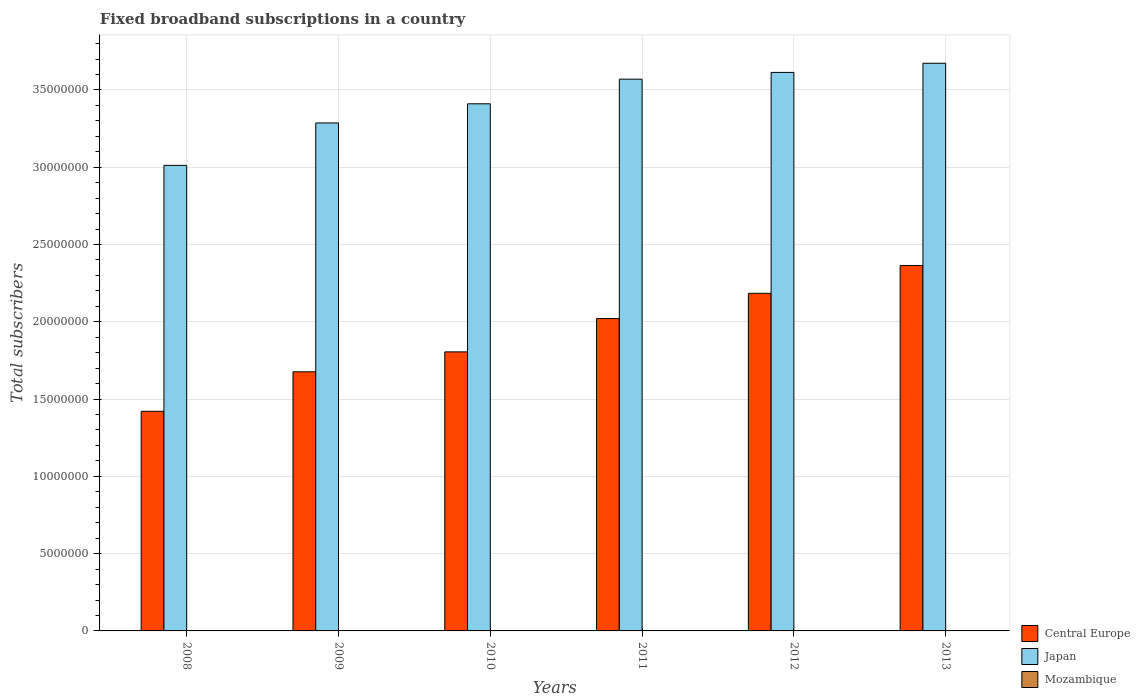How many different coloured bars are there?
Your answer should be very brief. 3. How many groups of bars are there?
Keep it short and to the point. 6. How many bars are there on the 3rd tick from the left?
Provide a short and direct response. 3. How many bars are there on the 1st tick from the right?
Provide a succinct answer. 3. In how many cases, is the number of bars for a given year not equal to the number of legend labels?
Offer a terse response. 0. What is the number of broadband subscriptions in Mozambique in 2011?
Give a very brief answer. 2.12e+04. Across all years, what is the maximum number of broadband subscriptions in Central Europe?
Make the answer very short. 2.36e+07. Across all years, what is the minimum number of broadband subscriptions in Japan?
Your response must be concise. 3.01e+07. In which year was the number of broadband subscriptions in Central Europe maximum?
Offer a very short reply. 2013. What is the total number of broadband subscriptions in Japan in the graph?
Provide a succinct answer. 2.06e+08. What is the difference between the number of broadband subscriptions in Japan in 2012 and that in 2013?
Give a very brief answer. -5.92e+05. What is the difference between the number of broadband subscriptions in Mozambique in 2012 and the number of broadband subscriptions in Central Europe in 2013?
Ensure brevity in your answer.  -2.36e+07. What is the average number of broadband subscriptions in Mozambique per year?
Give a very brief answer. 1.62e+04. In the year 2013, what is the difference between the number of broadband subscriptions in Japan and number of broadband subscriptions in Central Europe?
Your answer should be compact. 1.31e+07. What is the ratio of the number of broadband subscriptions in Japan in 2010 to that in 2013?
Offer a very short reply. 0.93. Is the number of broadband subscriptions in Japan in 2009 less than that in 2010?
Your response must be concise. Yes. What is the difference between the highest and the second highest number of broadband subscriptions in Japan?
Make the answer very short. 5.92e+05. What is the difference between the highest and the lowest number of broadband subscriptions in Japan?
Your answer should be compact. 6.61e+06. In how many years, is the number of broadband subscriptions in Mozambique greater than the average number of broadband subscriptions in Mozambique taken over all years?
Give a very brief answer. 3. Is the sum of the number of broadband subscriptions in Japan in 2008 and 2011 greater than the maximum number of broadband subscriptions in Mozambique across all years?
Offer a very short reply. Yes. What does the 1st bar from the left in 2008 represents?
Give a very brief answer. Central Europe. What does the 1st bar from the right in 2013 represents?
Provide a succinct answer. Mozambique. Is it the case that in every year, the sum of the number of broadband subscriptions in Mozambique and number of broadband subscriptions in Central Europe is greater than the number of broadband subscriptions in Japan?
Make the answer very short. No. How many bars are there?
Give a very brief answer. 18. Are all the bars in the graph horizontal?
Make the answer very short. No. What is the difference between two consecutive major ticks on the Y-axis?
Keep it short and to the point. 5.00e+06. Are the values on the major ticks of Y-axis written in scientific E-notation?
Provide a short and direct response. No. Where does the legend appear in the graph?
Offer a very short reply. Bottom right. How many legend labels are there?
Keep it short and to the point. 3. What is the title of the graph?
Your response must be concise. Fixed broadband subscriptions in a country. What is the label or title of the Y-axis?
Offer a terse response. Total subscribers. What is the Total subscribers in Central Europe in 2008?
Ensure brevity in your answer.  1.42e+07. What is the Total subscribers of Japan in 2008?
Ensure brevity in your answer.  3.01e+07. What is the Total subscribers of Mozambique in 2008?
Your response must be concise. 1.02e+04. What is the Total subscribers of Central Europe in 2009?
Keep it short and to the point. 1.68e+07. What is the Total subscribers of Japan in 2009?
Ensure brevity in your answer.  3.29e+07. What is the Total subscribers of Mozambique in 2009?
Your answer should be compact. 1.25e+04. What is the Total subscribers in Central Europe in 2010?
Make the answer very short. 1.81e+07. What is the Total subscribers of Japan in 2010?
Your answer should be very brief. 3.41e+07. What is the Total subscribers in Mozambique in 2010?
Your response must be concise. 1.46e+04. What is the Total subscribers in Central Europe in 2011?
Provide a short and direct response. 2.02e+07. What is the Total subscribers of Japan in 2011?
Provide a succinct answer. 3.57e+07. What is the Total subscribers in Mozambique in 2011?
Offer a very short reply. 2.12e+04. What is the Total subscribers in Central Europe in 2012?
Offer a terse response. 2.18e+07. What is the Total subscribers of Japan in 2012?
Your answer should be compact. 3.61e+07. What is the Total subscribers in Mozambique in 2012?
Offer a very short reply. 2.05e+04. What is the Total subscribers of Central Europe in 2013?
Provide a succinct answer. 2.36e+07. What is the Total subscribers of Japan in 2013?
Give a very brief answer. 3.67e+07. What is the Total subscribers in Mozambique in 2013?
Offer a very short reply. 1.80e+04. Across all years, what is the maximum Total subscribers of Central Europe?
Your answer should be compact. 2.36e+07. Across all years, what is the maximum Total subscribers of Japan?
Your answer should be very brief. 3.67e+07. Across all years, what is the maximum Total subscribers of Mozambique?
Offer a terse response. 2.12e+04. Across all years, what is the minimum Total subscribers in Central Europe?
Offer a terse response. 1.42e+07. Across all years, what is the minimum Total subscribers in Japan?
Keep it short and to the point. 3.01e+07. Across all years, what is the minimum Total subscribers in Mozambique?
Provide a succinct answer. 1.02e+04. What is the total Total subscribers of Central Europe in the graph?
Keep it short and to the point. 1.15e+08. What is the total Total subscribers of Japan in the graph?
Your answer should be compact. 2.06e+08. What is the total Total subscribers of Mozambique in the graph?
Your answer should be very brief. 9.70e+04. What is the difference between the Total subscribers in Central Europe in 2008 and that in 2009?
Give a very brief answer. -2.55e+06. What is the difference between the Total subscribers in Japan in 2008 and that in 2009?
Your answer should be very brief. -2.75e+06. What is the difference between the Total subscribers of Mozambique in 2008 and that in 2009?
Offer a terse response. -2311. What is the difference between the Total subscribers in Central Europe in 2008 and that in 2010?
Your answer should be very brief. -3.84e+06. What is the difference between the Total subscribers of Japan in 2008 and that in 2010?
Keep it short and to the point. -3.98e+06. What is the difference between the Total subscribers in Mozambique in 2008 and that in 2010?
Offer a terse response. -4442. What is the difference between the Total subscribers of Central Europe in 2008 and that in 2011?
Your answer should be very brief. -6.00e+06. What is the difference between the Total subscribers of Japan in 2008 and that in 2011?
Offer a very short reply. -5.58e+06. What is the difference between the Total subscribers of Mozambique in 2008 and that in 2011?
Keep it short and to the point. -1.10e+04. What is the difference between the Total subscribers in Central Europe in 2008 and that in 2012?
Your answer should be compact. -7.63e+06. What is the difference between the Total subscribers of Japan in 2008 and that in 2012?
Your response must be concise. -6.01e+06. What is the difference between the Total subscribers of Mozambique in 2008 and that in 2012?
Ensure brevity in your answer.  -1.03e+04. What is the difference between the Total subscribers in Central Europe in 2008 and that in 2013?
Your answer should be very brief. -9.43e+06. What is the difference between the Total subscribers of Japan in 2008 and that in 2013?
Your response must be concise. -6.61e+06. What is the difference between the Total subscribers in Mozambique in 2008 and that in 2013?
Make the answer very short. -7792. What is the difference between the Total subscribers of Central Europe in 2009 and that in 2010?
Your answer should be compact. -1.29e+06. What is the difference between the Total subscribers of Japan in 2009 and that in 2010?
Give a very brief answer. -1.24e+06. What is the difference between the Total subscribers of Mozambique in 2009 and that in 2010?
Your response must be concise. -2131. What is the difference between the Total subscribers in Central Europe in 2009 and that in 2011?
Offer a terse response. -3.45e+06. What is the difference between the Total subscribers of Japan in 2009 and that in 2011?
Keep it short and to the point. -2.83e+06. What is the difference between the Total subscribers in Mozambique in 2009 and that in 2011?
Give a very brief answer. -8702. What is the difference between the Total subscribers of Central Europe in 2009 and that in 2012?
Provide a short and direct response. -5.08e+06. What is the difference between the Total subscribers of Japan in 2009 and that in 2012?
Make the answer very short. -3.27e+06. What is the difference between the Total subscribers of Mozambique in 2009 and that in 2012?
Your answer should be compact. -7982. What is the difference between the Total subscribers in Central Europe in 2009 and that in 2013?
Your response must be concise. -6.87e+06. What is the difference between the Total subscribers of Japan in 2009 and that in 2013?
Give a very brief answer. -3.86e+06. What is the difference between the Total subscribers in Mozambique in 2009 and that in 2013?
Give a very brief answer. -5481. What is the difference between the Total subscribers in Central Europe in 2010 and that in 2011?
Your answer should be very brief. -2.16e+06. What is the difference between the Total subscribers in Japan in 2010 and that in 2011?
Your answer should be very brief. -1.59e+06. What is the difference between the Total subscribers of Mozambique in 2010 and that in 2011?
Provide a short and direct response. -6571. What is the difference between the Total subscribers in Central Europe in 2010 and that in 2012?
Give a very brief answer. -3.79e+06. What is the difference between the Total subscribers of Japan in 2010 and that in 2012?
Your answer should be compact. -2.03e+06. What is the difference between the Total subscribers in Mozambique in 2010 and that in 2012?
Your answer should be compact. -5851. What is the difference between the Total subscribers of Central Europe in 2010 and that in 2013?
Your response must be concise. -5.59e+06. What is the difference between the Total subscribers of Japan in 2010 and that in 2013?
Keep it short and to the point. -2.62e+06. What is the difference between the Total subscribers of Mozambique in 2010 and that in 2013?
Offer a very short reply. -3350. What is the difference between the Total subscribers in Central Europe in 2011 and that in 2012?
Keep it short and to the point. -1.63e+06. What is the difference between the Total subscribers in Japan in 2011 and that in 2012?
Your answer should be compact. -4.36e+05. What is the difference between the Total subscribers in Mozambique in 2011 and that in 2012?
Ensure brevity in your answer.  720. What is the difference between the Total subscribers of Central Europe in 2011 and that in 2013?
Your response must be concise. -3.43e+06. What is the difference between the Total subscribers of Japan in 2011 and that in 2013?
Give a very brief answer. -1.03e+06. What is the difference between the Total subscribers of Mozambique in 2011 and that in 2013?
Give a very brief answer. 3221. What is the difference between the Total subscribers of Central Europe in 2012 and that in 2013?
Your response must be concise. -1.80e+06. What is the difference between the Total subscribers of Japan in 2012 and that in 2013?
Give a very brief answer. -5.92e+05. What is the difference between the Total subscribers in Mozambique in 2012 and that in 2013?
Offer a terse response. 2501. What is the difference between the Total subscribers in Central Europe in 2008 and the Total subscribers in Japan in 2009?
Offer a terse response. -1.87e+07. What is the difference between the Total subscribers in Central Europe in 2008 and the Total subscribers in Mozambique in 2009?
Provide a succinct answer. 1.42e+07. What is the difference between the Total subscribers in Japan in 2008 and the Total subscribers in Mozambique in 2009?
Offer a terse response. 3.01e+07. What is the difference between the Total subscribers in Central Europe in 2008 and the Total subscribers in Japan in 2010?
Provide a succinct answer. -1.99e+07. What is the difference between the Total subscribers of Central Europe in 2008 and the Total subscribers of Mozambique in 2010?
Your answer should be compact. 1.42e+07. What is the difference between the Total subscribers of Japan in 2008 and the Total subscribers of Mozambique in 2010?
Your answer should be very brief. 3.01e+07. What is the difference between the Total subscribers in Central Europe in 2008 and the Total subscribers in Japan in 2011?
Make the answer very short. -2.15e+07. What is the difference between the Total subscribers in Central Europe in 2008 and the Total subscribers in Mozambique in 2011?
Offer a very short reply. 1.42e+07. What is the difference between the Total subscribers in Japan in 2008 and the Total subscribers in Mozambique in 2011?
Make the answer very short. 3.01e+07. What is the difference between the Total subscribers of Central Europe in 2008 and the Total subscribers of Japan in 2012?
Provide a short and direct response. -2.19e+07. What is the difference between the Total subscribers in Central Europe in 2008 and the Total subscribers in Mozambique in 2012?
Make the answer very short. 1.42e+07. What is the difference between the Total subscribers of Japan in 2008 and the Total subscribers of Mozambique in 2012?
Give a very brief answer. 3.01e+07. What is the difference between the Total subscribers in Central Europe in 2008 and the Total subscribers in Japan in 2013?
Keep it short and to the point. -2.25e+07. What is the difference between the Total subscribers in Central Europe in 2008 and the Total subscribers in Mozambique in 2013?
Your response must be concise. 1.42e+07. What is the difference between the Total subscribers in Japan in 2008 and the Total subscribers in Mozambique in 2013?
Your response must be concise. 3.01e+07. What is the difference between the Total subscribers in Central Europe in 2009 and the Total subscribers in Japan in 2010?
Provide a succinct answer. -1.73e+07. What is the difference between the Total subscribers in Central Europe in 2009 and the Total subscribers in Mozambique in 2010?
Make the answer very short. 1.67e+07. What is the difference between the Total subscribers in Japan in 2009 and the Total subscribers in Mozambique in 2010?
Your response must be concise. 3.28e+07. What is the difference between the Total subscribers of Central Europe in 2009 and the Total subscribers of Japan in 2011?
Make the answer very short. -1.89e+07. What is the difference between the Total subscribers of Central Europe in 2009 and the Total subscribers of Mozambique in 2011?
Give a very brief answer. 1.67e+07. What is the difference between the Total subscribers in Japan in 2009 and the Total subscribers in Mozambique in 2011?
Your answer should be compact. 3.28e+07. What is the difference between the Total subscribers of Central Europe in 2009 and the Total subscribers of Japan in 2012?
Make the answer very short. -1.94e+07. What is the difference between the Total subscribers of Central Europe in 2009 and the Total subscribers of Mozambique in 2012?
Offer a terse response. 1.67e+07. What is the difference between the Total subscribers in Japan in 2009 and the Total subscribers in Mozambique in 2012?
Your response must be concise. 3.28e+07. What is the difference between the Total subscribers of Central Europe in 2009 and the Total subscribers of Japan in 2013?
Provide a short and direct response. -2.00e+07. What is the difference between the Total subscribers in Central Europe in 2009 and the Total subscribers in Mozambique in 2013?
Provide a short and direct response. 1.67e+07. What is the difference between the Total subscribers of Japan in 2009 and the Total subscribers of Mozambique in 2013?
Provide a succinct answer. 3.28e+07. What is the difference between the Total subscribers in Central Europe in 2010 and the Total subscribers in Japan in 2011?
Provide a succinct answer. -1.76e+07. What is the difference between the Total subscribers of Central Europe in 2010 and the Total subscribers of Mozambique in 2011?
Provide a succinct answer. 1.80e+07. What is the difference between the Total subscribers in Japan in 2010 and the Total subscribers in Mozambique in 2011?
Give a very brief answer. 3.41e+07. What is the difference between the Total subscribers of Central Europe in 2010 and the Total subscribers of Japan in 2012?
Give a very brief answer. -1.81e+07. What is the difference between the Total subscribers of Central Europe in 2010 and the Total subscribers of Mozambique in 2012?
Your answer should be compact. 1.80e+07. What is the difference between the Total subscribers of Japan in 2010 and the Total subscribers of Mozambique in 2012?
Provide a succinct answer. 3.41e+07. What is the difference between the Total subscribers in Central Europe in 2010 and the Total subscribers in Japan in 2013?
Your answer should be compact. -1.87e+07. What is the difference between the Total subscribers of Central Europe in 2010 and the Total subscribers of Mozambique in 2013?
Offer a very short reply. 1.80e+07. What is the difference between the Total subscribers of Japan in 2010 and the Total subscribers of Mozambique in 2013?
Give a very brief answer. 3.41e+07. What is the difference between the Total subscribers in Central Europe in 2011 and the Total subscribers in Japan in 2012?
Make the answer very short. -1.59e+07. What is the difference between the Total subscribers of Central Europe in 2011 and the Total subscribers of Mozambique in 2012?
Provide a short and direct response. 2.02e+07. What is the difference between the Total subscribers in Japan in 2011 and the Total subscribers in Mozambique in 2012?
Ensure brevity in your answer.  3.57e+07. What is the difference between the Total subscribers in Central Europe in 2011 and the Total subscribers in Japan in 2013?
Offer a very short reply. -1.65e+07. What is the difference between the Total subscribers of Central Europe in 2011 and the Total subscribers of Mozambique in 2013?
Offer a very short reply. 2.02e+07. What is the difference between the Total subscribers in Japan in 2011 and the Total subscribers in Mozambique in 2013?
Offer a very short reply. 3.57e+07. What is the difference between the Total subscribers in Central Europe in 2012 and the Total subscribers in Japan in 2013?
Offer a terse response. -1.49e+07. What is the difference between the Total subscribers in Central Europe in 2012 and the Total subscribers in Mozambique in 2013?
Provide a short and direct response. 2.18e+07. What is the difference between the Total subscribers of Japan in 2012 and the Total subscribers of Mozambique in 2013?
Make the answer very short. 3.61e+07. What is the average Total subscribers of Central Europe per year?
Keep it short and to the point. 1.91e+07. What is the average Total subscribers in Japan per year?
Ensure brevity in your answer.  3.43e+07. What is the average Total subscribers in Mozambique per year?
Provide a succinct answer. 1.62e+04. In the year 2008, what is the difference between the Total subscribers of Central Europe and Total subscribers of Japan?
Make the answer very short. -1.59e+07. In the year 2008, what is the difference between the Total subscribers of Central Europe and Total subscribers of Mozambique?
Your answer should be compact. 1.42e+07. In the year 2008, what is the difference between the Total subscribers in Japan and Total subscribers in Mozambique?
Your answer should be compact. 3.01e+07. In the year 2009, what is the difference between the Total subscribers in Central Europe and Total subscribers in Japan?
Your answer should be very brief. -1.61e+07. In the year 2009, what is the difference between the Total subscribers of Central Europe and Total subscribers of Mozambique?
Offer a very short reply. 1.68e+07. In the year 2009, what is the difference between the Total subscribers of Japan and Total subscribers of Mozambique?
Provide a short and direct response. 3.29e+07. In the year 2010, what is the difference between the Total subscribers of Central Europe and Total subscribers of Japan?
Your answer should be very brief. -1.60e+07. In the year 2010, what is the difference between the Total subscribers in Central Europe and Total subscribers in Mozambique?
Keep it short and to the point. 1.80e+07. In the year 2010, what is the difference between the Total subscribers of Japan and Total subscribers of Mozambique?
Provide a short and direct response. 3.41e+07. In the year 2011, what is the difference between the Total subscribers of Central Europe and Total subscribers of Japan?
Keep it short and to the point. -1.55e+07. In the year 2011, what is the difference between the Total subscribers in Central Europe and Total subscribers in Mozambique?
Your response must be concise. 2.02e+07. In the year 2011, what is the difference between the Total subscribers of Japan and Total subscribers of Mozambique?
Make the answer very short. 3.57e+07. In the year 2012, what is the difference between the Total subscribers in Central Europe and Total subscribers in Japan?
Your answer should be compact. -1.43e+07. In the year 2012, what is the difference between the Total subscribers of Central Europe and Total subscribers of Mozambique?
Your response must be concise. 2.18e+07. In the year 2012, what is the difference between the Total subscribers of Japan and Total subscribers of Mozambique?
Keep it short and to the point. 3.61e+07. In the year 2013, what is the difference between the Total subscribers of Central Europe and Total subscribers of Japan?
Offer a terse response. -1.31e+07. In the year 2013, what is the difference between the Total subscribers in Central Europe and Total subscribers in Mozambique?
Offer a terse response. 2.36e+07. In the year 2013, what is the difference between the Total subscribers of Japan and Total subscribers of Mozambique?
Offer a very short reply. 3.67e+07. What is the ratio of the Total subscribers in Central Europe in 2008 to that in 2009?
Offer a very short reply. 0.85. What is the ratio of the Total subscribers in Japan in 2008 to that in 2009?
Provide a succinct answer. 0.92. What is the ratio of the Total subscribers of Mozambique in 2008 to that in 2009?
Give a very brief answer. 0.82. What is the ratio of the Total subscribers in Central Europe in 2008 to that in 2010?
Your response must be concise. 0.79. What is the ratio of the Total subscribers in Japan in 2008 to that in 2010?
Your answer should be compact. 0.88. What is the ratio of the Total subscribers in Mozambique in 2008 to that in 2010?
Give a very brief answer. 0.7. What is the ratio of the Total subscribers of Central Europe in 2008 to that in 2011?
Your answer should be very brief. 0.7. What is the ratio of the Total subscribers of Japan in 2008 to that in 2011?
Your answer should be very brief. 0.84. What is the ratio of the Total subscribers of Mozambique in 2008 to that in 2011?
Ensure brevity in your answer.  0.48. What is the ratio of the Total subscribers of Central Europe in 2008 to that in 2012?
Your response must be concise. 0.65. What is the ratio of the Total subscribers in Japan in 2008 to that in 2012?
Provide a short and direct response. 0.83. What is the ratio of the Total subscribers of Mozambique in 2008 to that in 2012?
Offer a terse response. 0.5. What is the ratio of the Total subscribers in Central Europe in 2008 to that in 2013?
Ensure brevity in your answer.  0.6. What is the ratio of the Total subscribers in Japan in 2008 to that in 2013?
Make the answer very short. 0.82. What is the ratio of the Total subscribers in Mozambique in 2008 to that in 2013?
Ensure brevity in your answer.  0.57. What is the ratio of the Total subscribers in Japan in 2009 to that in 2010?
Make the answer very short. 0.96. What is the ratio of the Total subscribers of Mozambique in 2009 to that in 2010?
Offer a very short reply. 0.85. What is the ratio of the Total subscribers of Central Europe in 2009 to that in 2011?
Provide a short and direct response. 0.83. What is the ratio of the Total subscribers of Japan in 2009 to that in 2011?
Keep it short and to the point. 0.92. What is the ratio of the Total subscribers in Mozambique in 2009 to that in 2011?
Keep it short and to the point. 0.59. What is the ratio of the Total subscribers of Central Europe in 2009 to that in 2012?
Offer a terse response. 0.77. What is the ratio of the Total subscribers of Japan in 2009 to that in 2012?
Ensure brevity in your answer.  0.91. What is the ratio of the Total subscribers in Mozambique in 2009 to that in 2012?
Provide a short and direct response. 0.61. What is the ratio of the Total subscribers of Central Europe in 2009 to that in 2013?
Make the answer very short. 0.71. What is the ratio of the Total subscribers of Japan in 2009 to that in 2013?
Keep it short and to the point. 0.89. What is the ratio of the Total subscribers of Mozambique in 2009 to that in 2013?
Provide a short and direct response. 0.7. What is the ratio of the Total subscribers in Central Europe in 2010 to that in 2011?
Make the answer very short. 0.89. What is the ratio of the Total subscribers in Japan in 2010 to that in 2011?
Your response must be concise. 0.96. What is the ratio of the Total subscribers of Mozambique in 2010 to that in 2011?
Keep it short and to the point. 0.69. What is the ratio of the Total subscribers of Central Europe in 2010 to that in 2012?
Provide a short and direct response. 0.83. What is the ratio of the Total subscribers in Japan in 2010 to that in 2012?
Your answer should be very brief. 0.94. What is the ratio of the Total subscribers of Mozambique in 2010 to that in 2012?
Provide a short and direct response. 0.71. What is the ratio of the Total subscribers in Central Europe in 2010 to that in 2013?
Your answer should be compact. 0.76. What is the ratio of the Total subscribers of Mozambique in 2010 to that in 2013?
Offer a terse response. 0.81. What is the ratio of the Total subscribers in Central Europe in 2011 to that in 2012?
Give a very brief answer. 0.93. What is the ratio of the Total subscribers in Japan in 2011 to that in 2012?
Offer a very short reply. 0.99. What is the ratio of the Total subscribers in Mozambique in 2011 to that in 2012?
Your answer should be compact. 1.04. What is the ratio of the Total subscribers of Central Europe in 2011 to that in 2013?
Your response must be concise. 0.85. What is the ratio of the Total subscribers of Japan in 2011 to that in 2013?
Keep it short and to the point. 0.97. What is the ratio of the Total subscribers of Mozambique in 2011 to that in 2013?
Your answer should be very brief. 1.18. What is the ratio of the Total subscribers in Central Europe in 2012 to that in 2013?
Your answer should be compact. 0.92. What is the ratio of the Total subscribers of Japan in 2012 to that in 2013?
Keep it short and to the point. 0.98. What is the ratio of the Total subscribers in Mozambique in 2012 to that in 2013?
Your response must be concise. 1.14. What is the difference between the highest and the second highest Total subscribers in Central Europe?
Offer a very short reply. 1.80e+06. What is the difference between the highest and the second highest Total subscribers of Japan?
Keep it short and to the point. 5.92e+05. What is the difference between the highest and the second highest Total subscribers of Mozambique?
Provide a succinct answer. 720. What is the difference between the highest and the lowest Total subscribers in Central Europe?
Keep it short and to the point. 9.43e+06. What is the difference between the highest and the lowest Total subscribers in Japan?
Ensure brevity in your answer.  6.61e+06. What is the difference between the highest and the lowest Total subscribers in Mozambique?
Give a very brief answer. 1.10e+04. 